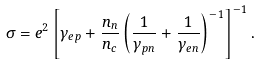Convert formula to latex. <formula><loc_0><loc_0><loc_500><loc_500>\sigma = e ^ { 2 } \left [ \gamma _ { e p } + \frac { n _ { n } } { n _ { c } } \left ( \frac { 1 } { \gamma _ { p n } } + \frac { 1 } { \gamma _ { e n } } \right ) ^ { - 1 } \right ] ^ { - 1 } .</formula> 